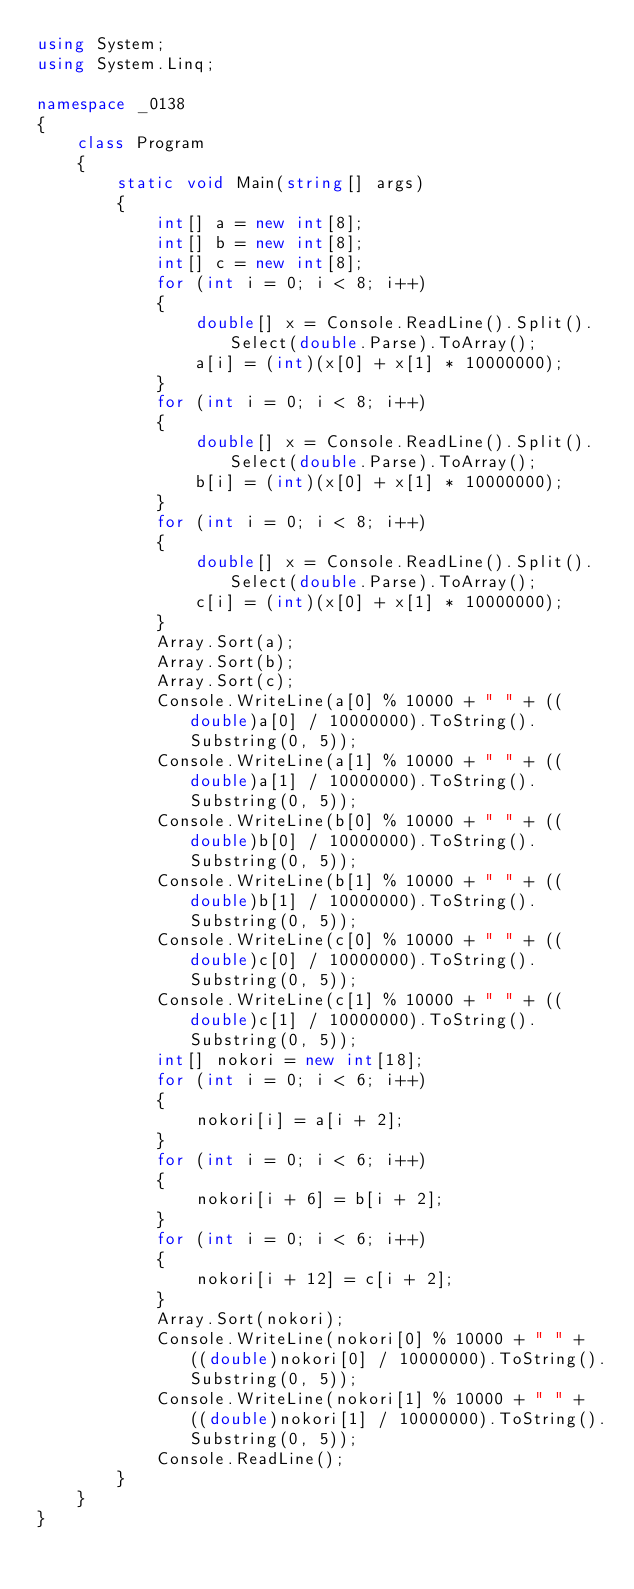<code> <loc_0><loc_0><loc_500><loc_500><_C#_>using System;
using System.Linq;

namespace _0138
{
    class Program
    {
        static void Main(string[] args)
        {
            int[] a = new int[8];
            int[] b = new int[8];
            int[] c = new int[8];
            for (int i = 0; i < 8; i++)
            {
                double[] x = Console.ReadLine().Split().Select(double.Parse).ToArray();
                a[i] = (int)(x[0] + x[1] * 10000000);
            }
            for (int i = 0; i < 8; i++)
            {
                double[] x = Console.ReadLine().Split().Select(double.Parse).ToArray();
                b[i] = (int)(x[0] + x[1] * 10000000);
            }
            for (int i = 0; i < 8; i++)
            {
                double[] x = Console.ReadLine().Split().Select(double.Parse).ToArray();
                c[i] = (int)(x[0] + x[1] * 10000000);
            }
            Array.Sort(a);
            Array.Sort(b);
            Array.Sort(c);
            Console.WriteLine(a[0] % 10000 + " " + ((double)a[0] / 10000000).ToString().Substring(0, 5));
            Console.WriteLine(a[1] % 10000 + " " + ((double)a[1] / 10000000).ToString().Substring(0, 5));
            Console.WriteLine(b[0] % 10000 + " " + ((double)b[0] / 10000000).ToString().Substring(0, 5));
            Console.WriteLine(b[1] % 10000 + " " + ((double)b[1] / 10000000).ToString().Substring(0, 5));
            Console.WriteLine(c[0] % 10000 + " " + ((double)c[0] / 10000000).ToString().Substring(0, 5));
            Console.WriteLine(c[1] % 10000 + " " + ((double)c[1] / 10000000).ToString().Substring(0, 5));
            int[] nokori = new int[18];
            for (int i = 0; i < 6; i++)
            {
                nokori[i] = a[i + 2];
            }
            for (int i = 0; i < 6; i++)
            {
                nokori[i + 6] = b[i + 2];
            }
            for (int i = 0; i < 6; i++)
            {
                nokori[i + 12] = c[i + 2];
            }
            Array.Sort(nokori);
            Console.WriteLine(nokori[0] % 10000 + " " + ((double)nokori[0] / 10000000).ToString().Substring(0, 5));
            Console.WriteLine(nokori[1] % 10000 + " " + ((double)nokori[1] / 10000000).ToString().Substring(0, 5));
            Console.ReadLine();
        }
    }
}</code> 